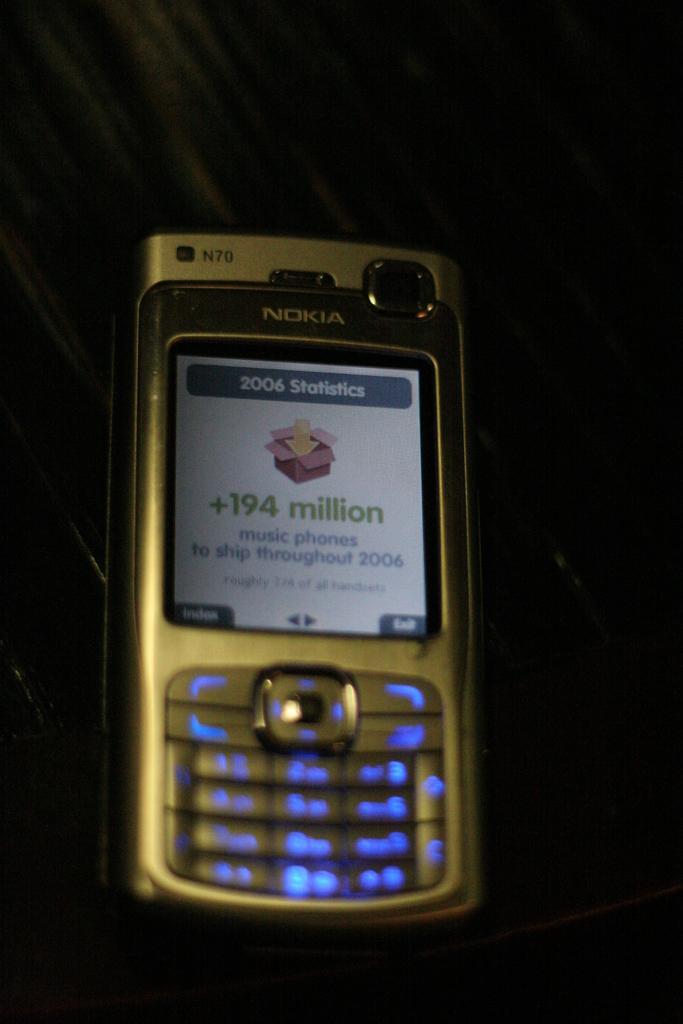Please provide a concise description of this image. In this image I can see a mobile phone. I can see few button and screen. Something is written on it. Background is in black color. 